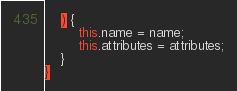<code> <loc_0><loc_0><loc_500><loc_500><_Haxe_>    ) {
        this.name = name;
        this.attributes = attributes;
    }
}
</code> 